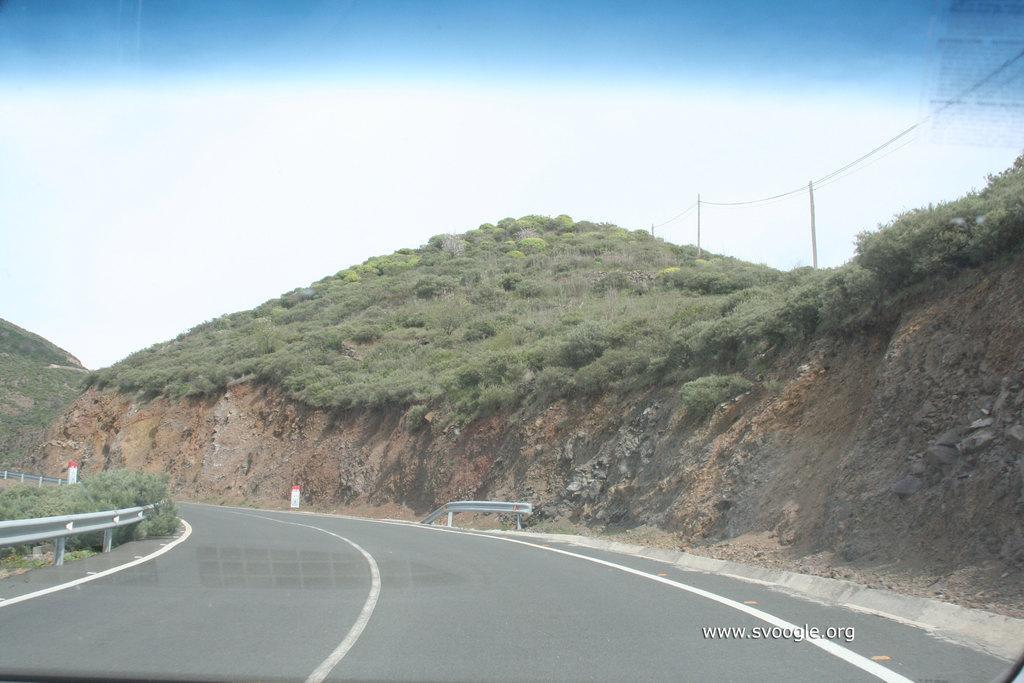How would you summarize this image in a sentence or two? In this image we can see the road, hills, pole, wires, trees and sky in the background. 